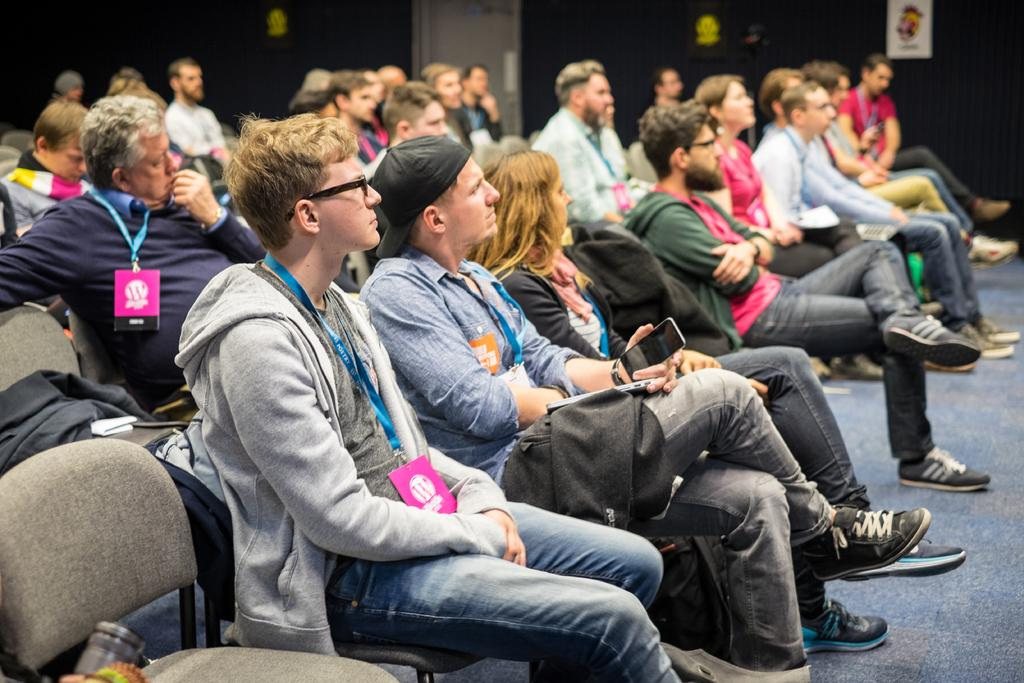How many people are present in the image? There are many people in the image. What are the people doing in the image? The people are sitting on chairs. What can be seen hanging around the necks of the people in the image? The people are wearing ID cards. What type of meal is being served on the hot cork in the image? There is no meal or cork present in the image; it only features people sitting on chairs and wearing ID cards. 